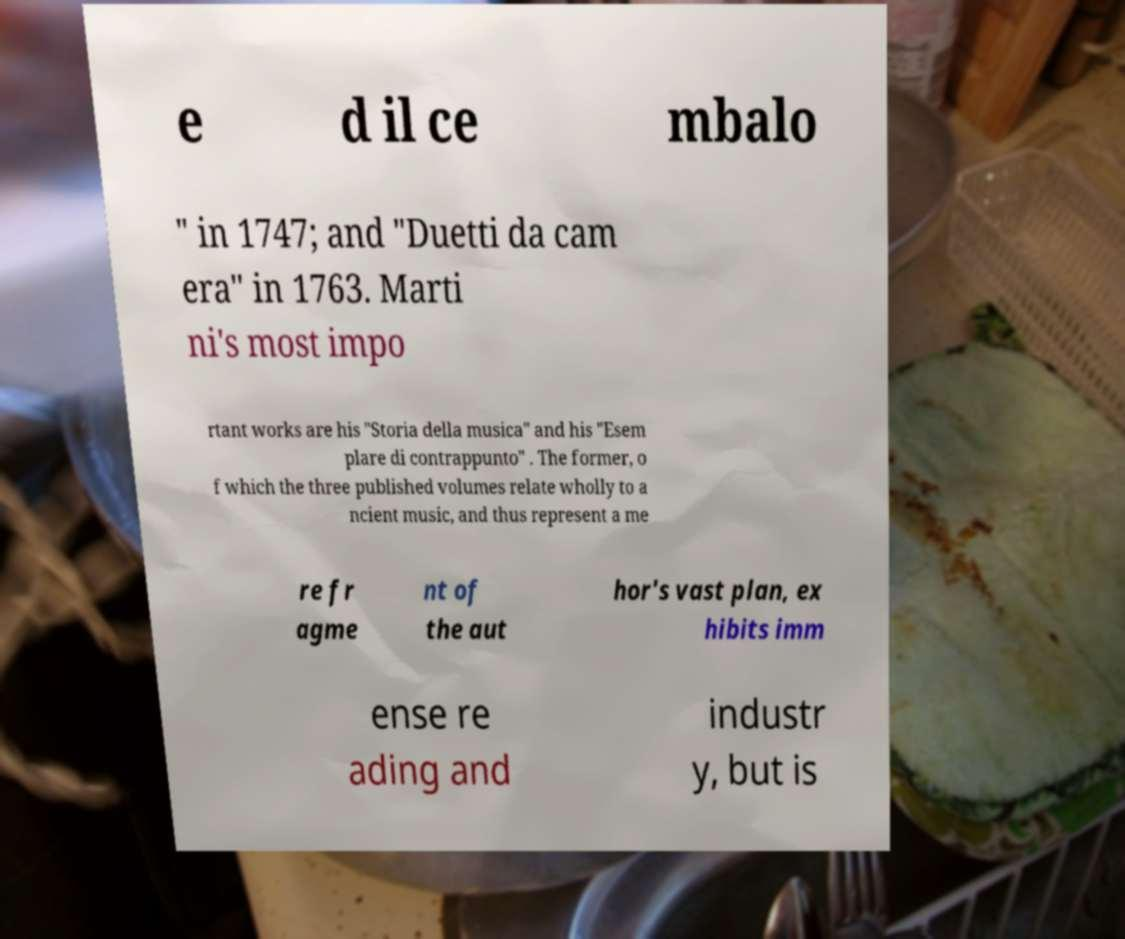Can you read and provide the text displayed in the image?This photo seems to have some interesting text. Can you extract and type it out for me? e d il ce mbalo " in 1747; and "Duetti da cam era" in 1763. Marti ni's most impo rtant works are his "Storia della musica" and his "Esem plare di contrappunto" . The former, o f which the three published volumes relate wholly to a ncient music, and thus represent a me re fr agme nt of the aut hor's vast plan, ex hibits imm ense re ading and industr y, but is 